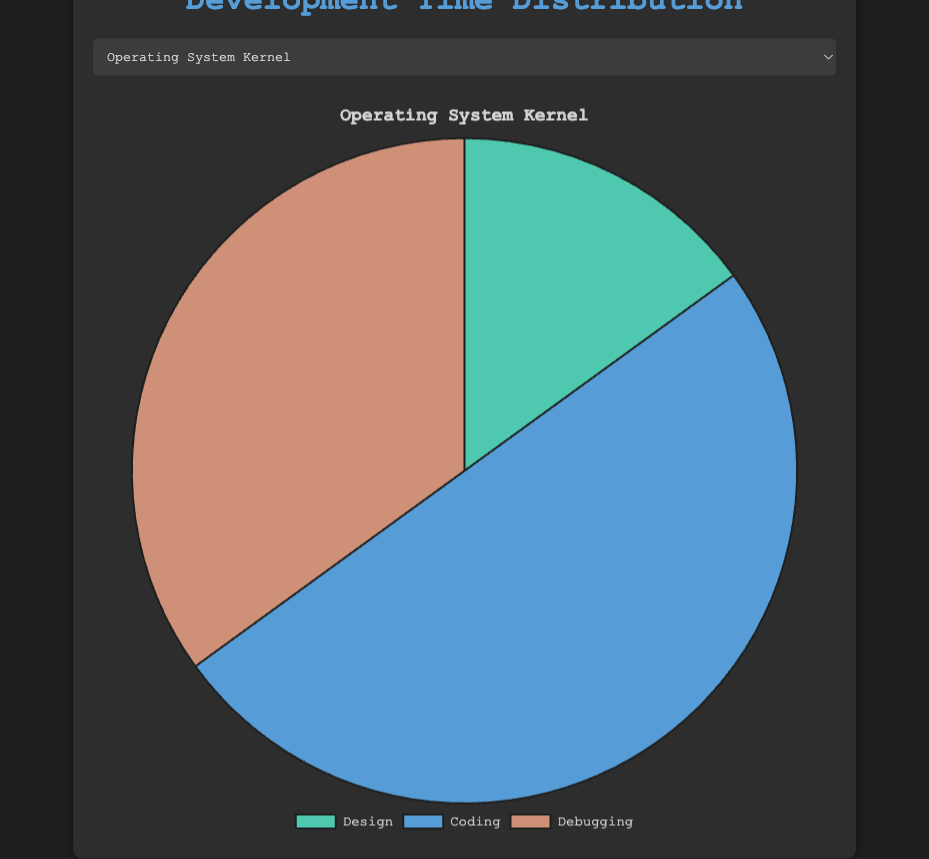What is the percentage of time spent on Coding for the 'Device Driver' project? To find the percentage of time spent on Coding for the 'Device Driver' project, look at the given data. It shows 60% of the time is spent on Coding.
Answer: 60% Which project allocates the highest percentage of time to Design? To determine which project allocates the highest percentage of time to Design, compare the Design percentages across all projects. The highest Design percentage is for the 'Real-Time OS Scheduler' project at 30%.
Answer: Real-Time OS Scheduler Compare the Debugging phase time for 'Operating System Kernel' and 'Embedded System Controller'. Which one spends more time? Compare the Debugging times: Operating System Kernel has 35% and Embedded System Controller has 25%. Thus, Operating System Kernel spends more time on Debugging.
Answer: Operating System Kernel What is the total percentage of time spent on Coding and Debugging combined for the 'Game Engine' project? Add the Coding (45%) and Debugging (30%) times for the 'Game Engine' project: 45% + 30% = 75%.
Answer: 75% Which project has the smallest percentage of time allocated to Debugging? Compare the Debugging percentages across all projects. The smallest Debugging percentage is for the 'Device Driver' project at 20%.
Answer: Device Driver For the 'Embedded System Controller' project, what is the difference in percentage between Coding and Design phases? Subtract the Design percentage (20%) from the Coding percentage (55%) for the 'Embedded System Controller' project: 55% - 20% = 35%.
Answer: 35% Is the percentage of time spent on Design for 'Game Engine' more or less than 'Device Driver'? Compare the Design percentages: Game Engine has 25% and Device Driver has 20%. Therefore, Game Engine spends more time on Design.
Answer: More Sum the percentages of all phases for the 'Operating System Kernel' project. Does it equal 100%? Add all the phase percentages for the Operating System Kernel project: 15% (Design) + 50% (Coding) + 35% (Debugging) = 100%.
Answer: Yes Which project spends an equal percentage of time on Coding and Debugging? Identify which project's Coding and Debugging percentages are equal. The 'Real-Time OS Scheduler' project spends 40% on Coding and 30% on Debugging, which is equal across projects.
Answer: Real-Time OS Scheduler 